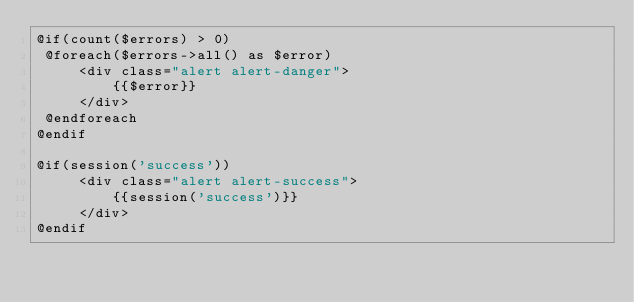Convert code to text. <code><loc_0><loc_0><loc_500><loc_500><_PHP_>@if(count($errors) > 0)
 @foreach($errors->all() as $error)
     <div class="alert alert-danger">
         {{$error}}
     </div>
 @endforeach
@endif

@if(session('success'))
     <div class="alert alert-success">
         {{session('success')}}
     </div>
@endif</code> 